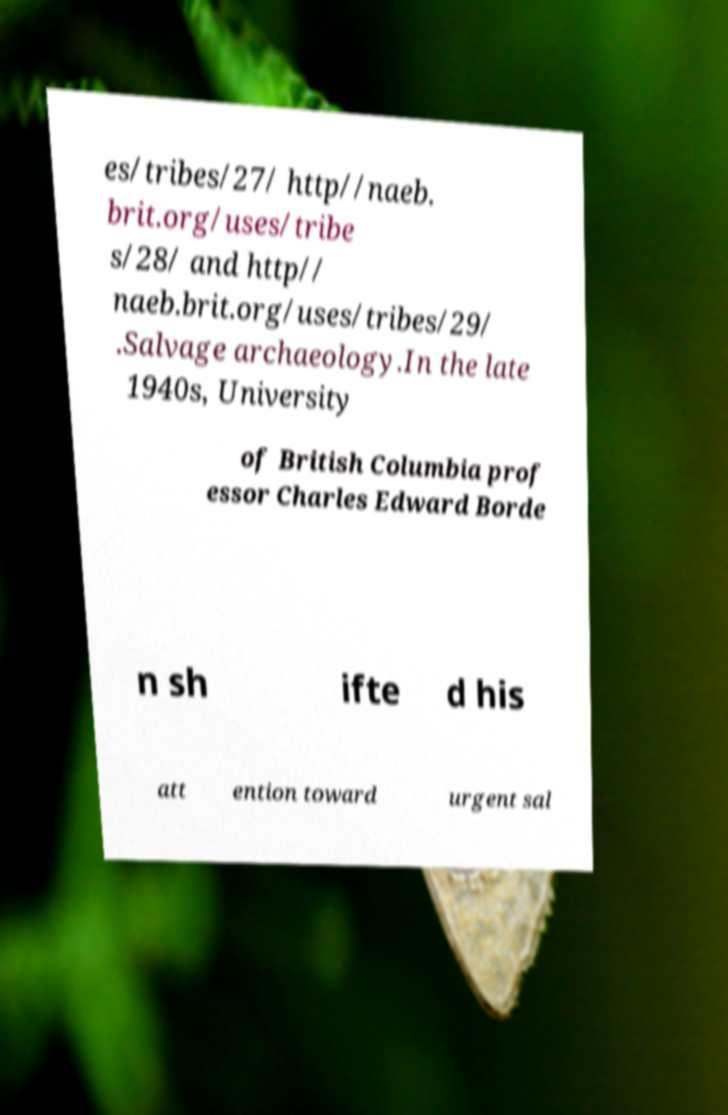Could you extract and type out the text from this image? es/tribes/27/ http//naeb. brit.org/uses/tribe s/28/ and http// naeb.brit.org/uses/tribes/29/ .Salvage archaeology.In the late 1940s, University of British Columbia prof essor Charles Edward Borde n sh ifte d his att ention toward urgent sal 